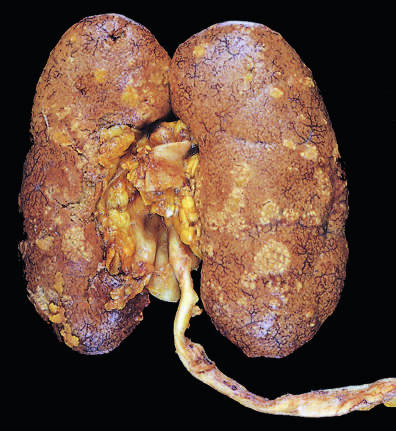what is the cortical surface studded with?
Answer the question using a single word or phrase. Focal pale abscesses 